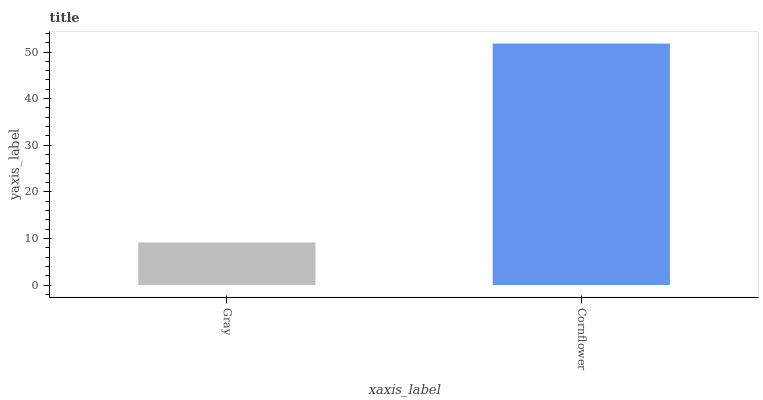Is Gray the minimum?
Answer yes or no. Yes. Is Cornflower the maximum?
Answer yes or no. Yes. Is Cornflower the minimum?
Answer yes or no. No. Is Cornflower greater than Gray?
Answer yes or no. Yes. Is Gray less than Cornflower?
Answer yes or no. Yes. Is Gray greater than Cornflower?
Answer yes or no. No. Is Cornflower less than Gray?
Answer yes or no. No. Is Cornflower the high median?
Answer yes or no. Yes. Is Gray the low median?
Answer yes or no. Yes. Is Gray the high median?
Answer yes or no. No. Is Cornflower the low median?
Answer yes or no. No. 